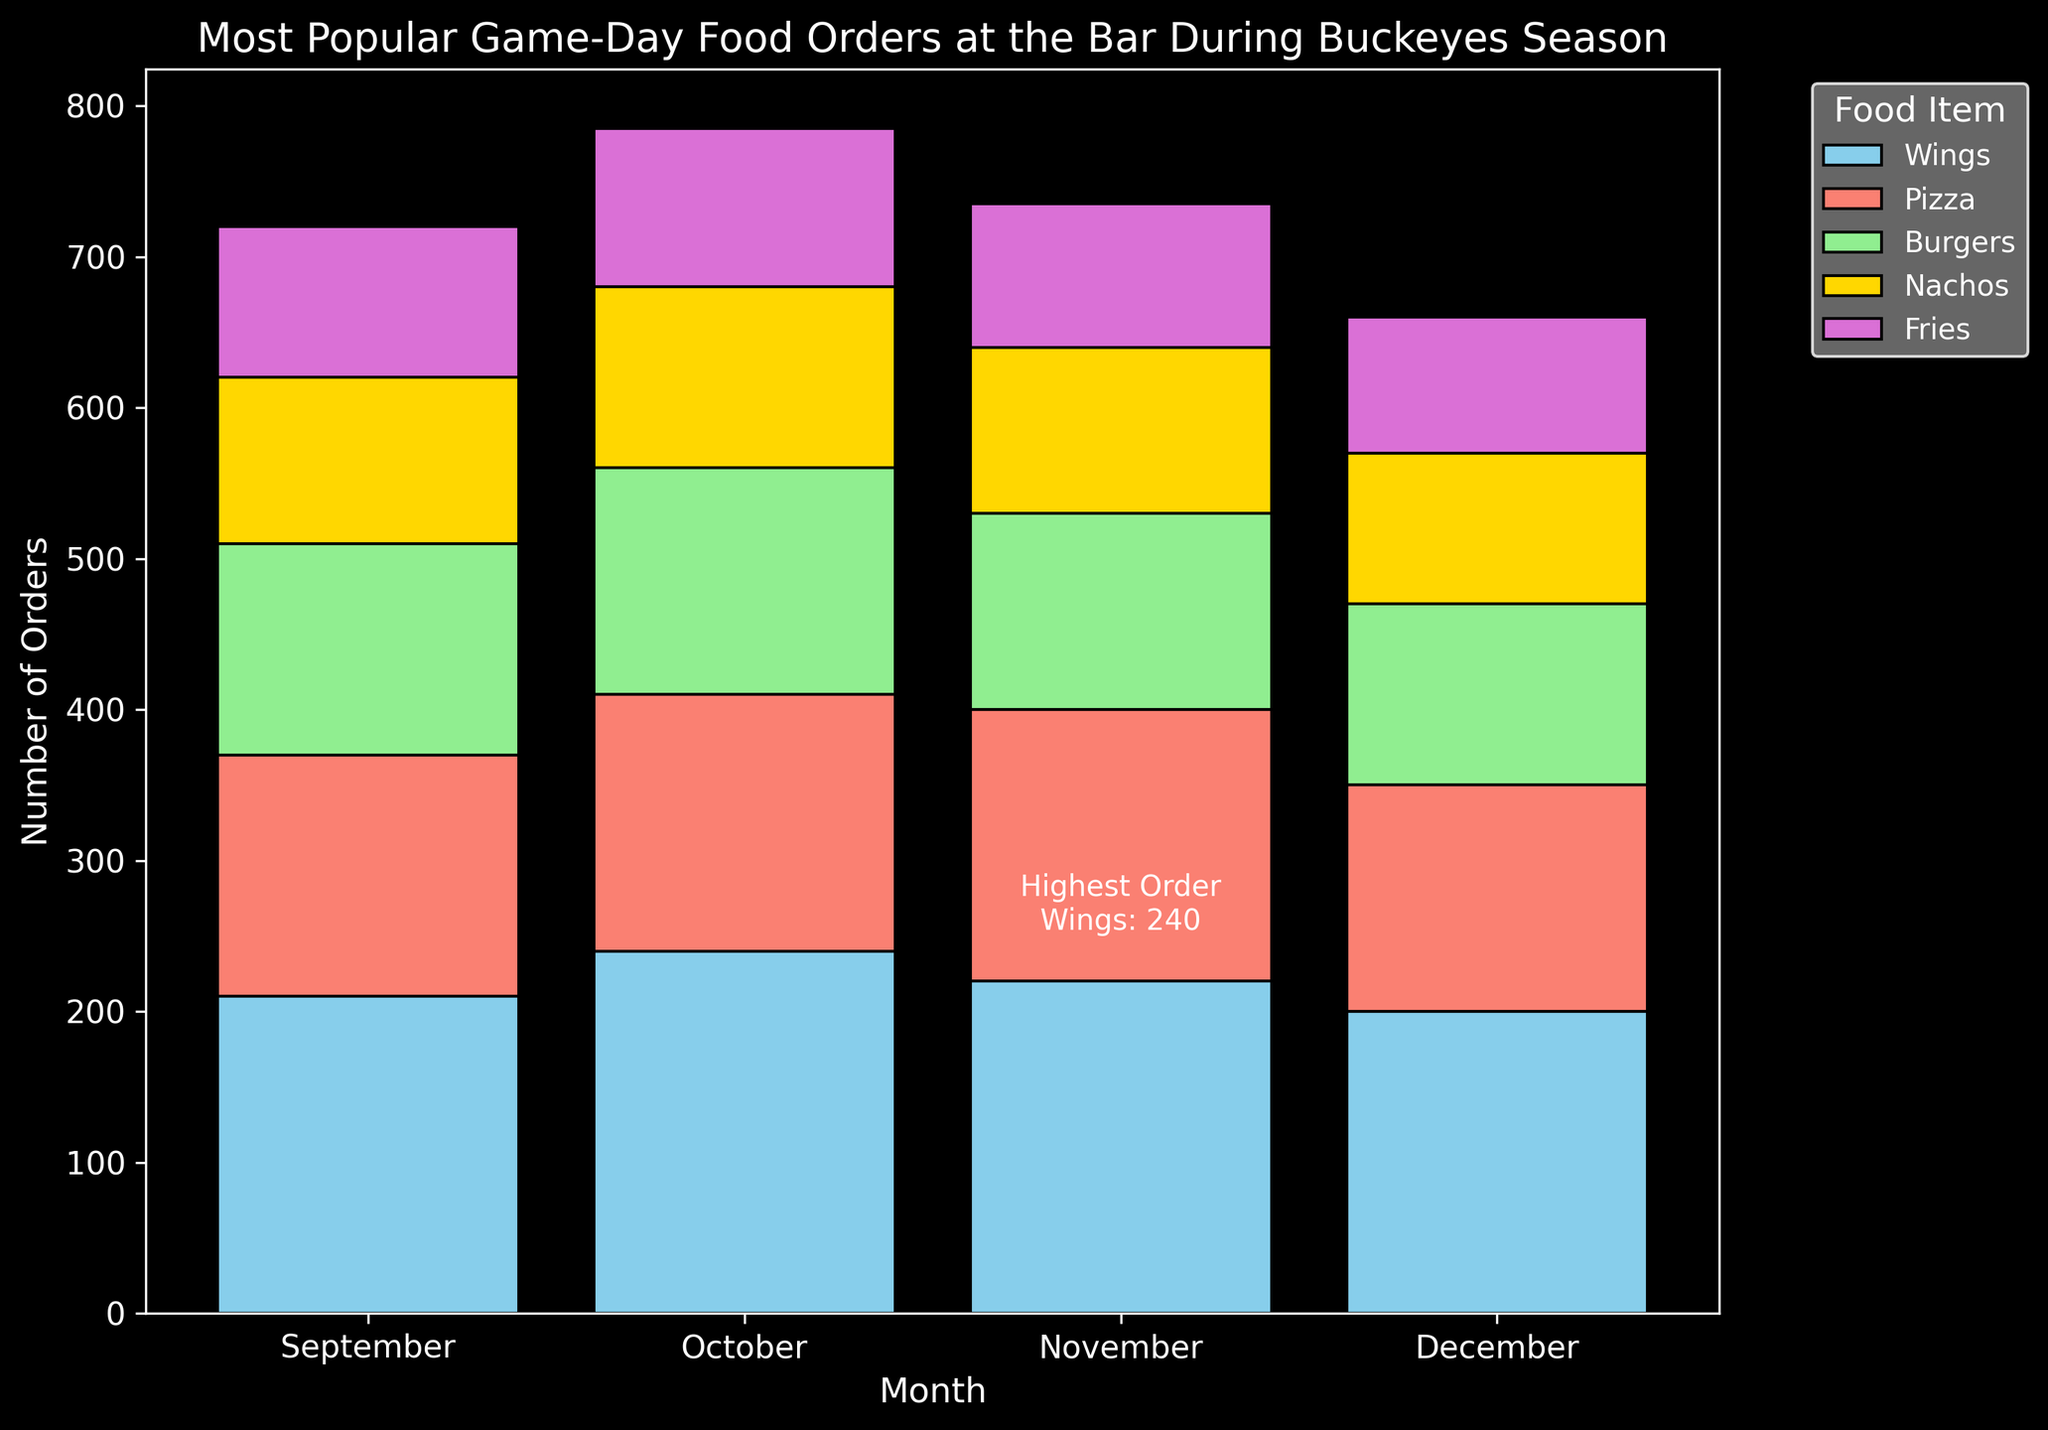What is the most ordered food item in November? The bar chart indicates the orders for each food item across different months. Observing November, the tallest bar represents Wings, making it the most ordered food item for that month.
Answer: Wings Which month had the highest total orders for Wings? The bar chart shows the height of the Wings bars for each month. November's bar is the tallest, indicating the highest total orders for Wings.
Answer: November How many more orders did Pizza have in October compared to September? From the chart, Pizza had 180 orders in October and 150 in September. The difference is 180 - 150.
Answer: 30 Which month had the lowest total orders for Fries? The bar chart shows the orders for Fries each month. September has the shortest bar for Fries, indicating the lowest total orders.
Answer: September What is the combined total of orders for Burgers in October and December? According to the chart, Burgers had 130 orders in October and 140 in December. Adding them together gives 130 + 140.
Answer: 270 What is the color of the bar representing Nachos? Each food item has a different color in the bar chart. Nachos are represented by a gold bar.
Answer: Gold In which month did the total orders for Pizza decrease compared to the previous month? Comparing the Pizza orders month by month: September (150), October (180), November (170), and December (160). The decrease is from October (180) to November (170) and from November (170) to December (160).
Answer: November and December Which month had the highest total number of food orders overall? Summing the heights of all bars for each month, November has the highest combined height, indicating the highest total food orders.
Answer: November How many total orders for Nachos are there in December? The bar chart shows that the number of orders for Nachos in December is 110.
Answer: 110 What annotation is displayed on the chart, and what does it signify? The annotation on the chart indicates 'Highest Order: Wings: 240' highlighting the highest number of total orders for Wings in November.
Answer: Highest Order: Wings: 240 